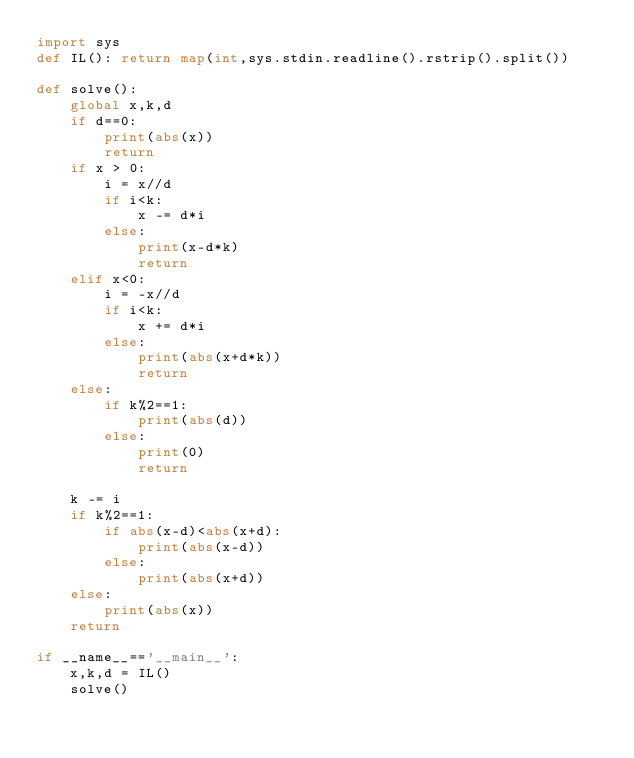<code> <loc_0><loc_0><loc_500><loc_500><_Python_>import sys
def IL(): return map(int,sys.stdin.readline().rstrip().split())

def solve():
    global x,k,d
    if d==0:
        print(abs(x))
        return
    if x > 0:
        i = x//d
        if i<k:
            x -= d*i
        else:
            print(x-d*k)
            return
    elif x<0:
        i = -x//d
        if i<k:
            x += d*i
        else:
            print(abs(x+d*k))
            return
    else:
        if k%2==1:
            print(abs(d))
        else:
            print(0)
            return
    
    k -= i
    if k%2==1:
        if abs(x-d)<abs(x+d):
            print(abs(x-d))
        else:
            print(abs(x+d))
    else:
        print(abs(x))
    return

if __name__=='__main__':
    x,k,d = IL()
    solve()</code> 